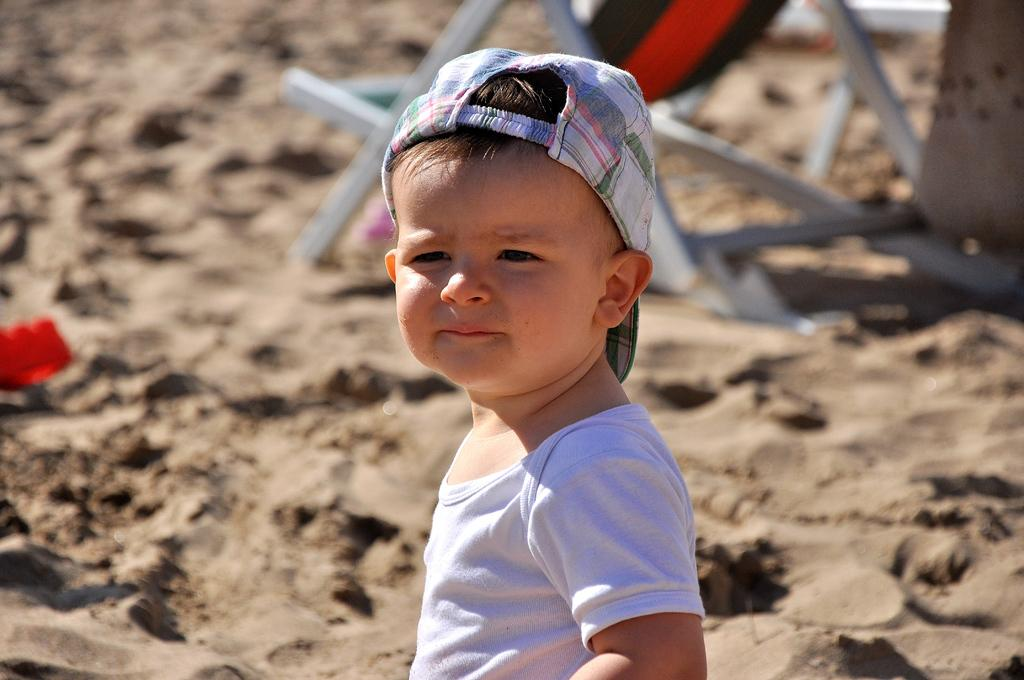What is the main subject of the image? There is a child in the image. What is the child wearing? The child is wearing a white t-shirt and a cap. What can be seen in the background of the image? There is a chair and a red-colored object in the background of the image. Can you describe the chair in the background? The chair is white, black, and red in color, and it is on the sand. What type of island is visible in the background of the image? There is no island visible in the background of the image. What kind of apparatus is being used by the child in the image? There is no apparatus being used by the child in the image; the child is simply standing or sitting. 